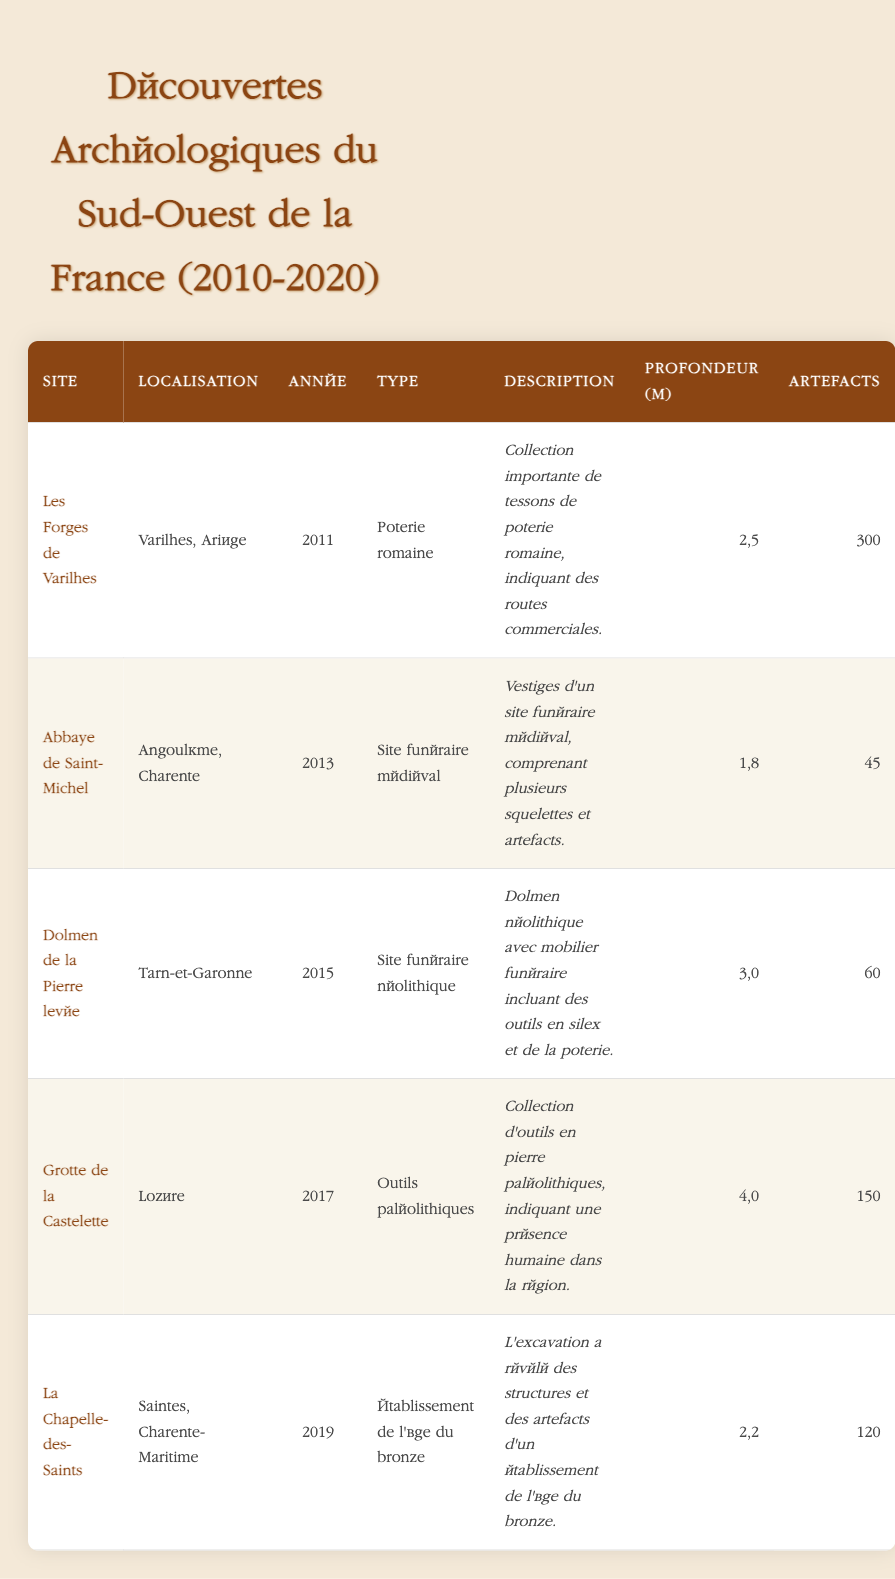What year was the Abbey of Saint-Michel discovered? The table shows that the Abbey of Saint-Michel was discovered in the year listed in the "Année" column. By looking at the row for the Abbey of Saint-Michel, I see that the year is 2013.
Answer: 2013 Which site contains artifacts from the Bronze Age? In the "Type" column, I check for any references to the Bronze Age. The row for La Chapelle-des-Saints indicates it is a settlement from the Bronze Age.
Answer: La Chapelle-des-Saints How many artifacts were found at the Grotte de la Castelette? By checking the "Artefacts" column for the Grotte de la Castelette, I find the corresponding value in that row which is 150 artifacts.
Answer: 150 What is the average excavation depth in meters of all the sites listed? I first gather the excavation depths from each site: 2.5, 1.8, 3.0, 4.0, and 2.2. Summing these gives 2.5 + 1.8 + 3.0 + 4.0 + 2.2 = 13.5. Then, dividing by the number of sites (5) gives an average depth of 13.5 / 5 = 2.7 meters.
Answer: 2.7 Is there evidence of human presence in the region at the Grotte de la Castelette? The description for Grotte de la Castelette states that it contains a collection of Paleolithic stone tools indicating human presence. Therefore, the statement is true.
Answer: Yes Which site, discovered in 2015, had the fewest artifacts? I check the rows for sites discovered in 2015. The Dolmen de la Pierre levée is the only site for that year, with 60 artifacts found. Therefore, it must have had the fewest artifacts for that year.
Answer: Dolmen de la Pierre levée What type of artifacts were primarily found at Les Forges de Varilhes? The "Type" column for Les Forges de Varilhes specifies Roman pottery. I can refer to this row directly to answer the question.
Answer: Roman pottery Which two sites had more than 100 artifacts found? Inspecting the "Artefacts" column, I see that Les Forges de Varilhes (300 artifacts) and Grotte de la Castelette (150 artifacts) both exceed 100 artifacts.
Answer: Les Forges de Varilhes and Grotte de la Castelette 